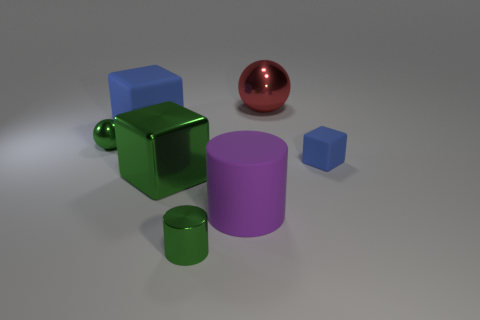Are there more big blue spheres than cylinders?
Ensure brevity in your answer.  No. There is a matte thing that is the same color as the tiny rubber block; what size is it?
Your answer should be compact. Large. There is a small object in front of the blue rubber block in front of the big matte cube; what shape is it?
Provide a short and direct response. Cylinder. There is a blue block that is to the right of the big cube that is behind the large green cube; is there a small shiny object that is in front of it?
Provide a short and direct response. Yes. There is a metal cylinder that is the same size as the green shiny sphere; what color is it?
Your answer should be compact. Green. There is a object that is both left of the red ball and on the right side of the small green cylinder; what is its shape?
Offer a terse response. Cylinder. There is a block in front of the object right of the big red shiny sphere; what is its size?
Offer a terse response. Large. How many big metal spheres are the same color as the big matte block?
Offer a terse response. 0. How many other things are the same size as the green sphere?
Give a very brief answer. 2. There is a matte thing that is to the left of the large red metallic object and in front of the large blue rubber thing; what is its size?
Offer a terse response. Large. 